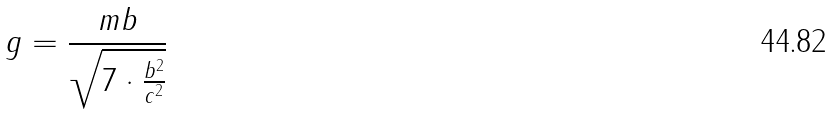Convert formula to latex. <formula><loc_0><loc_0><loc_500><loc_500>g = \frac { m b } { \sqrt { 7 \cdot \frac { b ^ { 2 } } { c ^ { 2 } } } }</formula> 